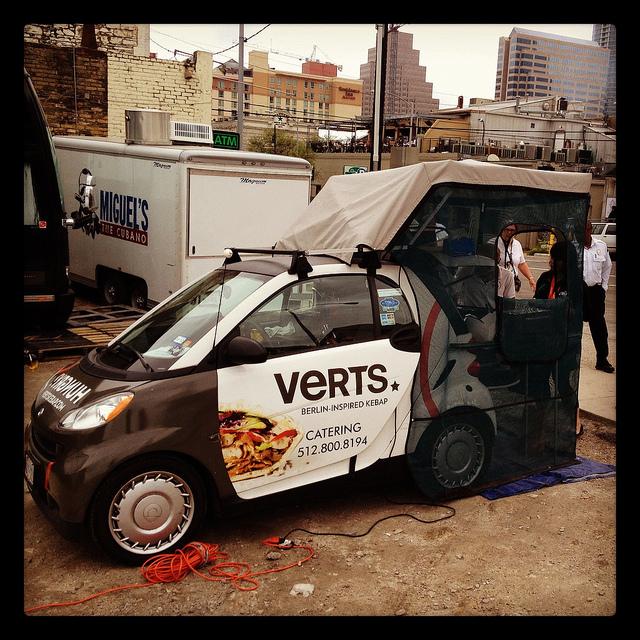Can this car be crushed in an accident?
Be succinct. Yes. Is this a city street?
Concise answer only. No. What company is sponsoring the truck?
Answer briefly. Verts. Who caters on the side of this car?
Write a very short answer. Verts. Is this car suitable for camping?
Write a very short answer. No. 